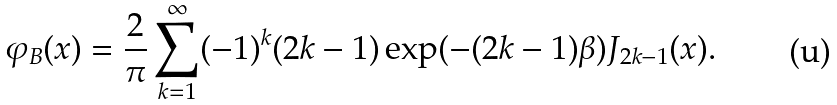<formula> <loc_0><loc_0><loc_500><loc_500>\varphi _ { B } ( x ) = \frac { 2 } { \pi } \sum _ { k = 1 } ^ { \infty } ( - 1 ) ^ { k } ( 2 k - 1 ) \exp ( - ( 2 k - 1 ) \beta ) J _ { 2 k - 1 } ( x ) .</formula> 